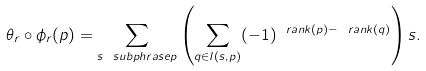<formula> <loc_0><loc_0><loc_500><loc_500>\theta _ { r } \circ \phi _ { r } ( p ) = \sum _ { s \ s u b p h r a s e p } \left ( \sum _ { q \in I ( s , p ) } ( - 1 ) ^ { \ r a n k ( p ) - \ r a n k ( q ) } \right ) s .</formula> 